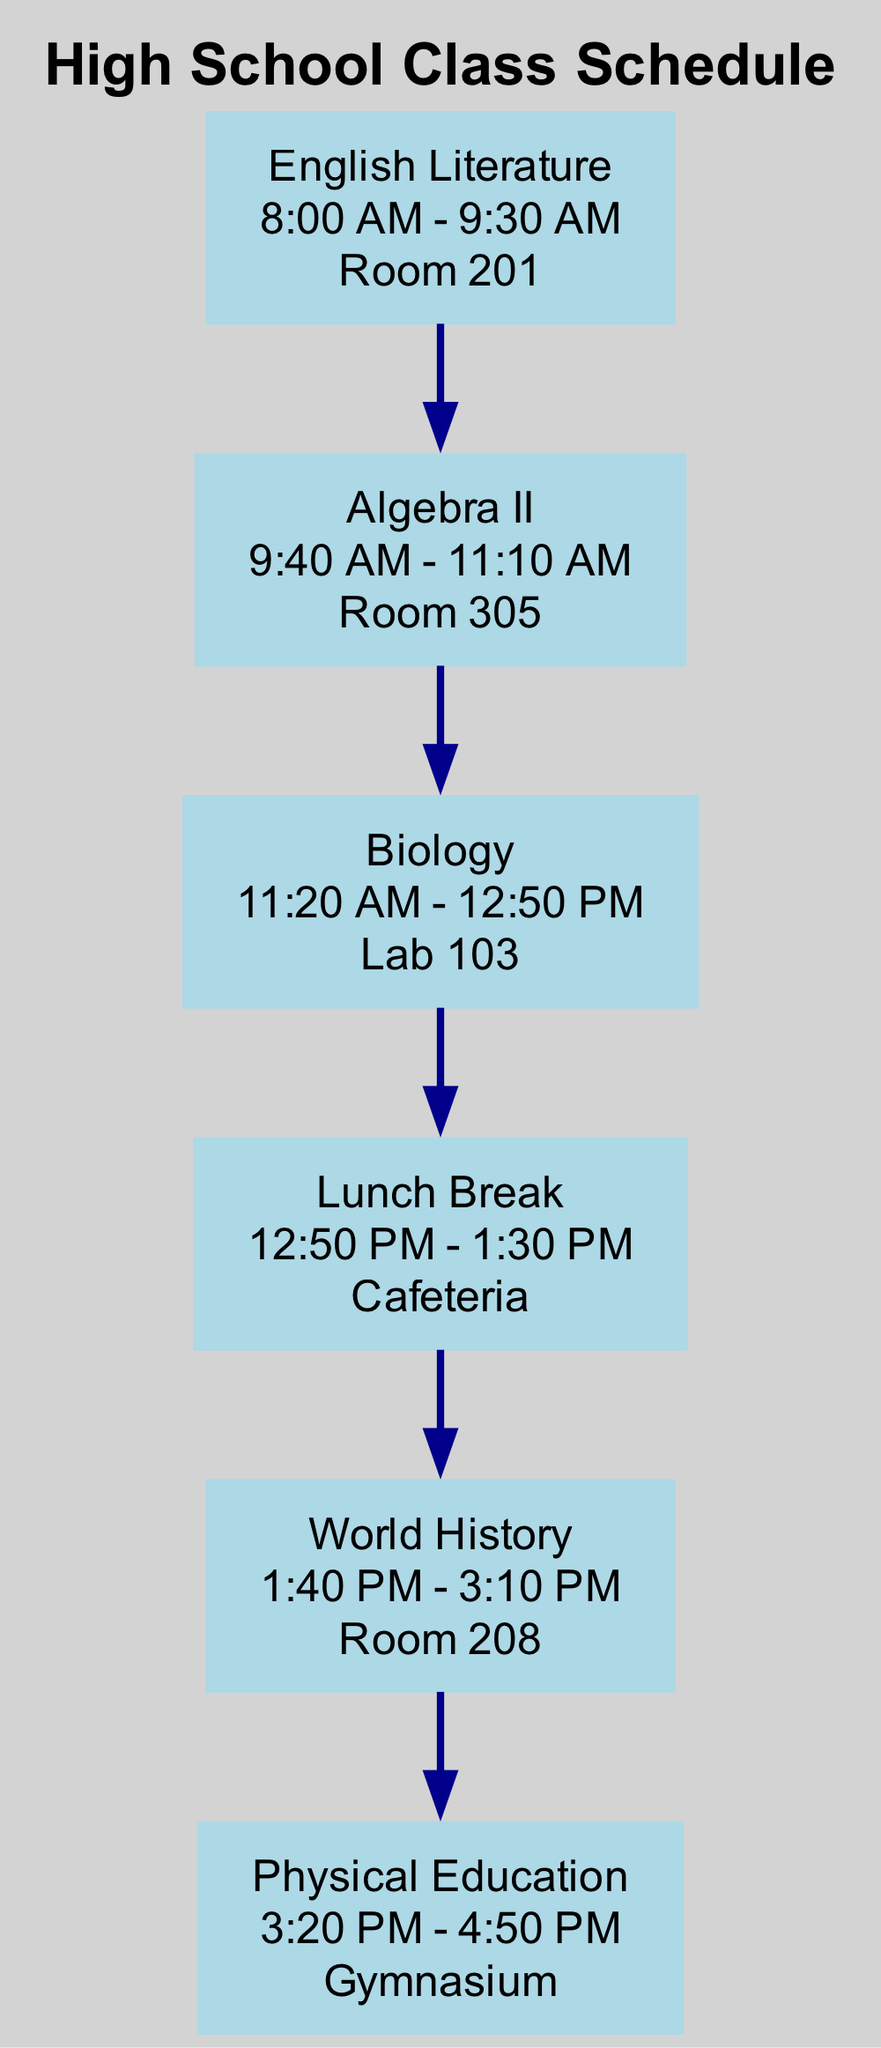What subject is scheduled from 8:00 AM to 9:30 AM? The diagram shows that the subject scheduled during this time is English Literature, as listed at the top of the schedule.
Answer: English Literature How many total subjects are listed in the schedule? By counting the different subjects shown in the diagram, we see that there are six subjects: English Literature, Algebra II, Biology, World History, Physical Education, and a Lunch Break.
Answer: Six What room is Biology held in? Referring to the schedule, it specifies that Biology is held in Lab 103, clearly indicated under the Biology subject node.
Answer: Lab 103 Which subject immediately follows Algebra II in the schedule? The flow of the diagram shows that after Algebra II, the next subject listed is Biology, represented through the connecting edge from Algebra II to Biology.
Answer: Biology What time does the Lunch Break occur? In the diagram, the Lunch Break is scheduled from 12:50 PM to 1:30 PM, as detailed in the Lunch Break node.
Answer: 12:50 PM - 1:30 PM What is the last subject of the day? Looking at the schedule, the last subject listed is Physical Education, as it is positioned at the end of the flow in the diagram.
Answer: Physical Education Which room is World History held in? According to the diagram, the World History class takes place in Room 208, which is specified in the node for World History.
Answer: Room 208 How much time is allocated for the Lunch Break? By analyzing the schedule, the Lunch Break is allocated a total of 40 minutes, running from 12:50 PM to 1:30 PM.
Answer: 40 minutes What room is used for Physical Education classes? The diagram specifies that Physical Education classes are conducted in the Gymnasium, which is marked in the Physical Education node.
Answer: Gymnasium 